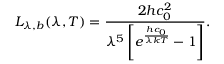<formula> <loc_0><loc_0><loc_500><loc_500>L _ { \lambda , b } ( \lambda , T ) = \frac { 2 h c _ { 0 } ^ { 2 } } { \lambda ^ { 5 } \left [ e ^ { \frac { h c _ { 0 } } { \lambda k T } } - 1 \right ] } .</formula> 